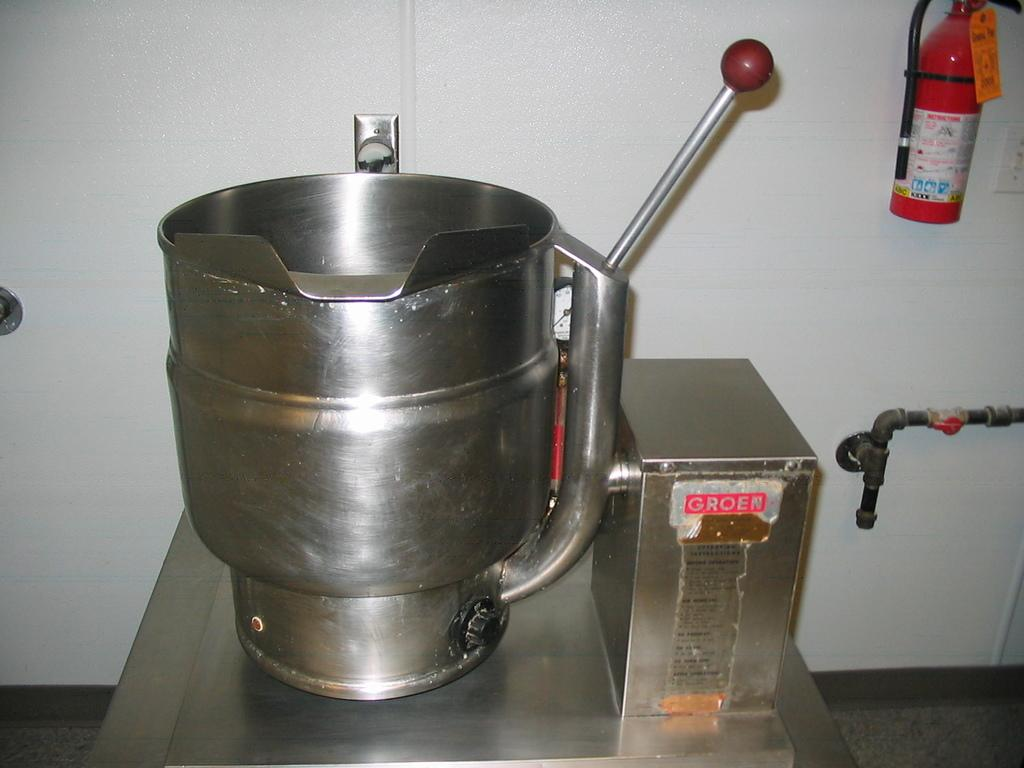<image>
Present a compact description of the photo's key features. A silver grinder with a handle and Groen power box. 